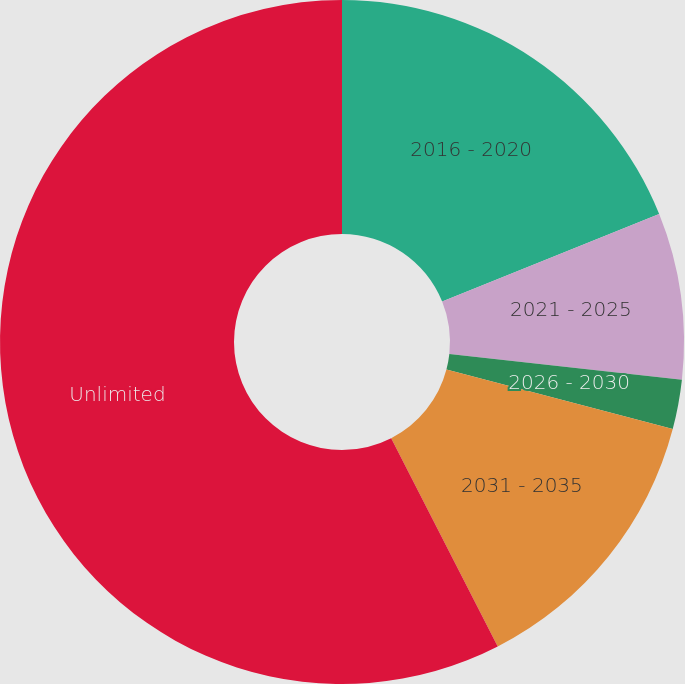Convert chart. <chart><loc_0><loc_0><loc_500><loc_500><pie_chart><fcel>2016 - 2020<fcel>2021 - 2025<fcel>2026 - 2030<fcel>2031 - 2035<fcel>Unlimited<nl><fcel>18.9%<fcel>7.86%<fcel>2.34%<fcel>13.38%<fcel>57.53%<nl></chart> 